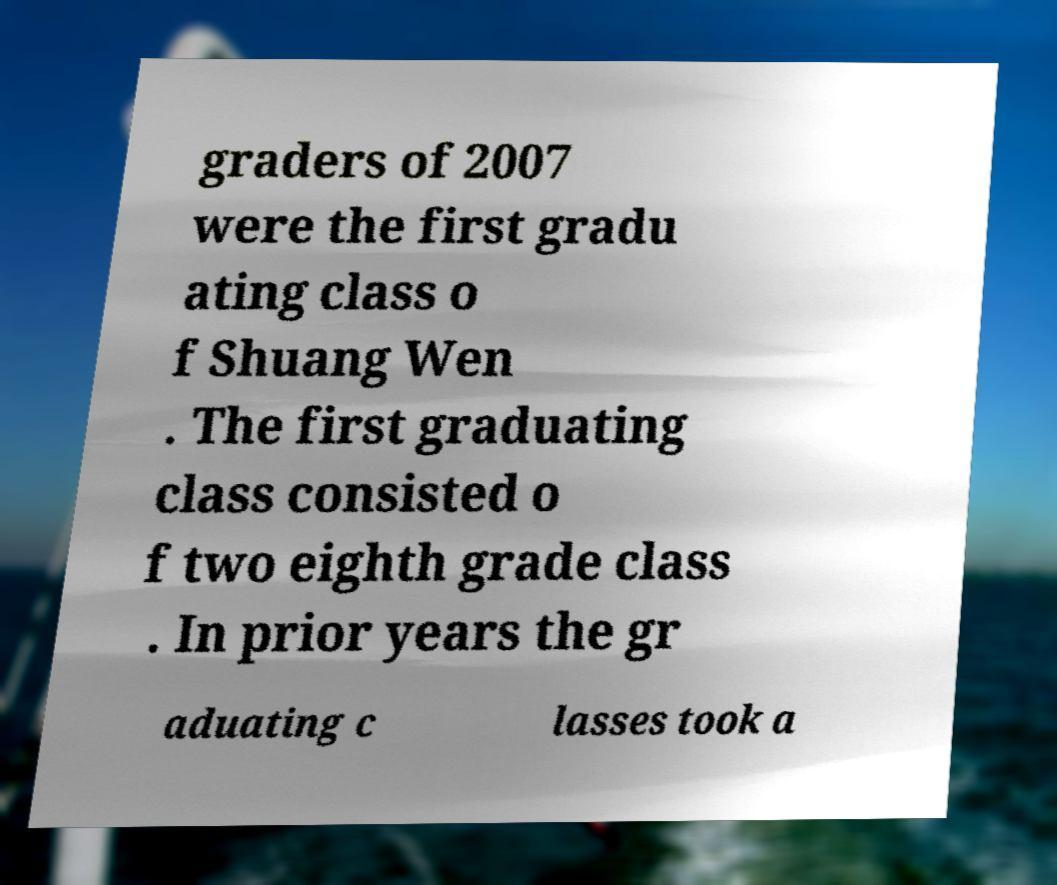Could you extract and type out the text from this image? graders of 2007 were the first gradu ating class o f Shuang Wen . The first graduating class consisted o f two eighth grade class . In prior years the gr aduating c lasses took a 